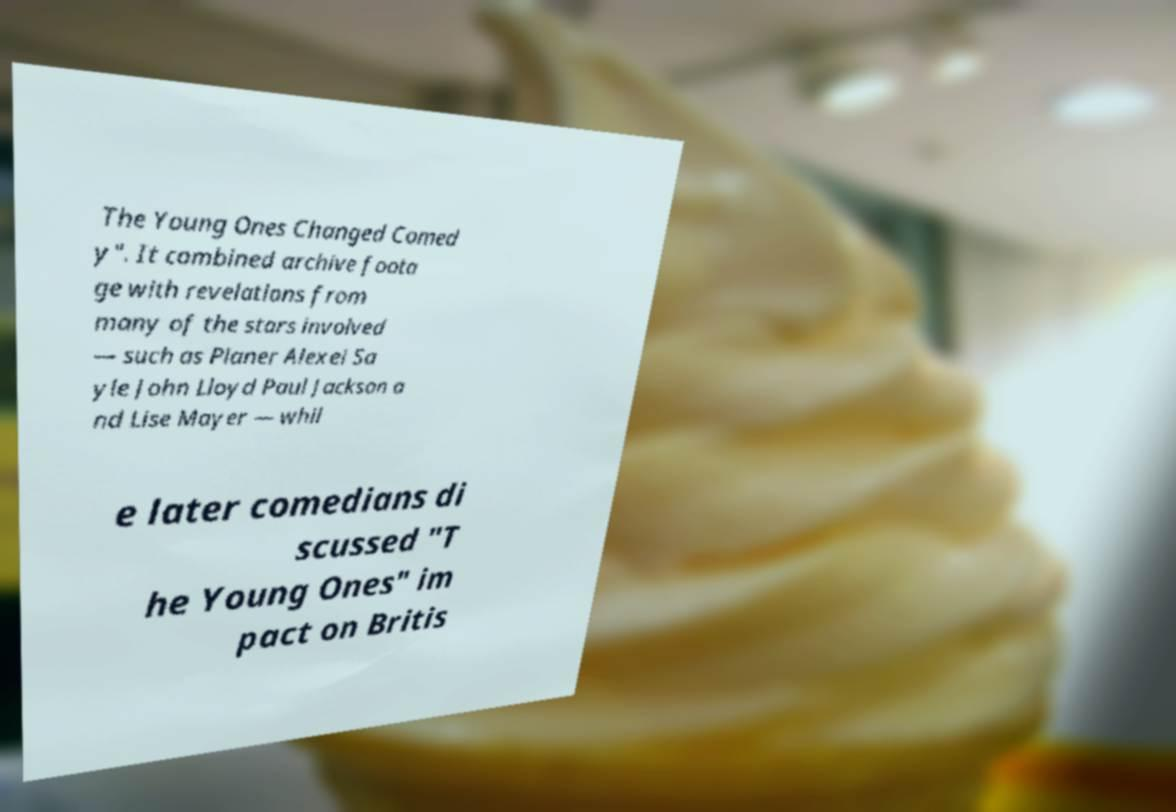Can you accurately transcribe the text from the provided image for me? The Young Ones Changed Comed y". It combined archive foota ge with revelations from many of the stars involved — such as Planer Alexei Sa yle John Lloyd Paul Jackson a nd Lise Mayer — whil e later comedians di scussed "T he Young Ones" im pact on Britis 